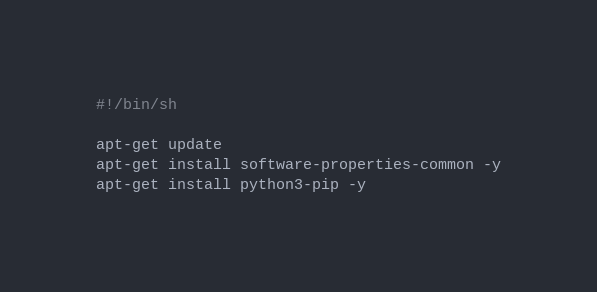Convert code to text. <code><loc_0><loc_0><loc_500><loc_500><_Bash_>#!/bin/sh

apt-get update
apt-get install software-properties-common -y
apt-get install python3-pip -y
</code> 